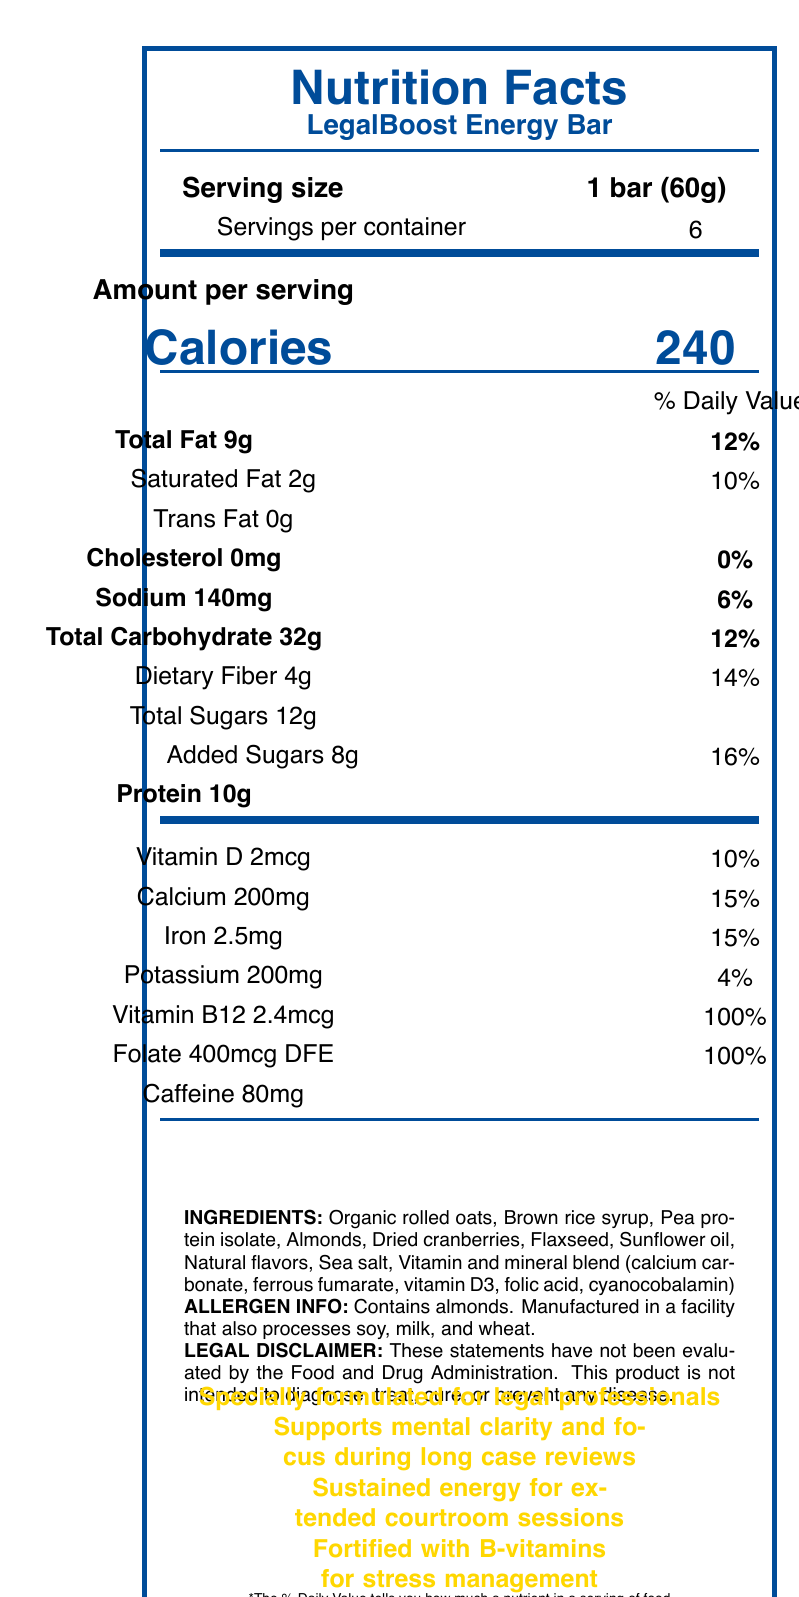what is the serving size? The serving size is clearly mentioned as "1 bar (60g)" in the document.
Answer: 1 bar (60g) how many servings are there per container? The document specifies that there are 6 servings per container
Answer: 6 servings how many calories are in one serving of the LegalBoost Energy Bar? The document states that each serving contains 240 calories.
Answer: 240 calories what percentage of the daily value is the added sugars in one serving? The document indicates that added sugars constitute 16% of the daily value in one serving.
Answer: 16% what is the total amount of protein in one serving? The amount of protein in one serving is 10g, which is listed in the document.
Answer: 10g which ingredient is not listed in the LegalBoost Energy Bar? A. Almonds B. Peanuts C. Flaxseed D. Organic rolled oats The document lists "Almonds," "Flaxseed," and "Organic rolled oats" as ingredients, but does not mention "Peanuts."
Answer: B. Peanuts how much dietary fiber does one serving contain? A. 2g B. 14g C. 4g D. 6g The document lists the amount of dietary fiber per serving as 4g.
Answer: C. 4g does the product contain any caffeine? The document lists that one serving contains 80mg of caffeine.
Answer: Yes does LegalBoost Energy Bar contain trans fat? The document specifies that the trans fat content is 0g.
Answer: No summarize the main idea of this document. The document is a Nutrition Facts Label for LegalBoost Energy Bar, providing details on serving size, calories, and the amount and daily value percentage of various nutrients. It includes ingredients, allergen information, and marketing claims targeting legal professionals.
Answer: Nutrition Facts Label for LegalBoost Energy Bar what is the percentage of vitamin B12 per serving? The document states that the vitamin B12 content per serving is 100% of the daily value.
Answer: 100% is this product free of allergens? The document mentions allergen info indicating that the product contains almonds and is manufactured in a facility that also processes soy, milk, and wheat.
Answer: No how much calcium does one serving contain? The document specifies that each serving contains 200mg of calcium.
Answer: 200mg how many total carbohydrates are in one serving? The document lists the total carbohydrates as 32g per serving.
Answer: 32g what nutrients are listed under the vitamin and mineral blend in the ingredients? The document lists these specific vitamins and minerals as part of the blend in the ingredients section.
Answer: calcium carbonate, ferrous fumarate, vitamin D3, folic acid, cyanocobalamin how much vitamin D is in one serving? The document specifies that each serving contains 2mcg of vitamin D.
Answer: 2mcg which of the following is a marketing claim of the LegalBoost Energy Bar? A. Gluten-free B. Fortified with B-vitamins for stress management C. Contains no added sugars D. Low sodium The document lists "Fortified with B-vitamins for stress management" as one of the marketing claims.
Answer: B. Fortified with B-vitamins for stress management what is the percentage of daily value of sodium in one serving? The document lists the percentage of daily value for sodium as 6%.
Answer: 6% does the product intend to diagnose, treat, cure, or prevent any disease? The legal disclaimer at the bottom of the document states that the product is not intended to diagnose, treat, cure, or prevent any disease.
Answer: No what is the exact role of vitamin b12 in the LegalBoost Energy Bar's formulation? The document does not specify the exact role of vitamin B12 beyond its percentage daily value and presence as part of the vitamin and mineral blend.
Answer: Not enough information 